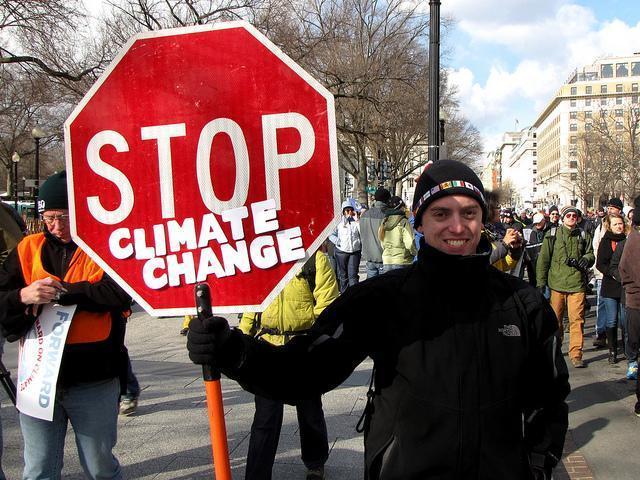How many people are in the photo?
Give a very brief answer. 7. How many chairs are on the left side of the table?
Give a very brief answer. 0. 